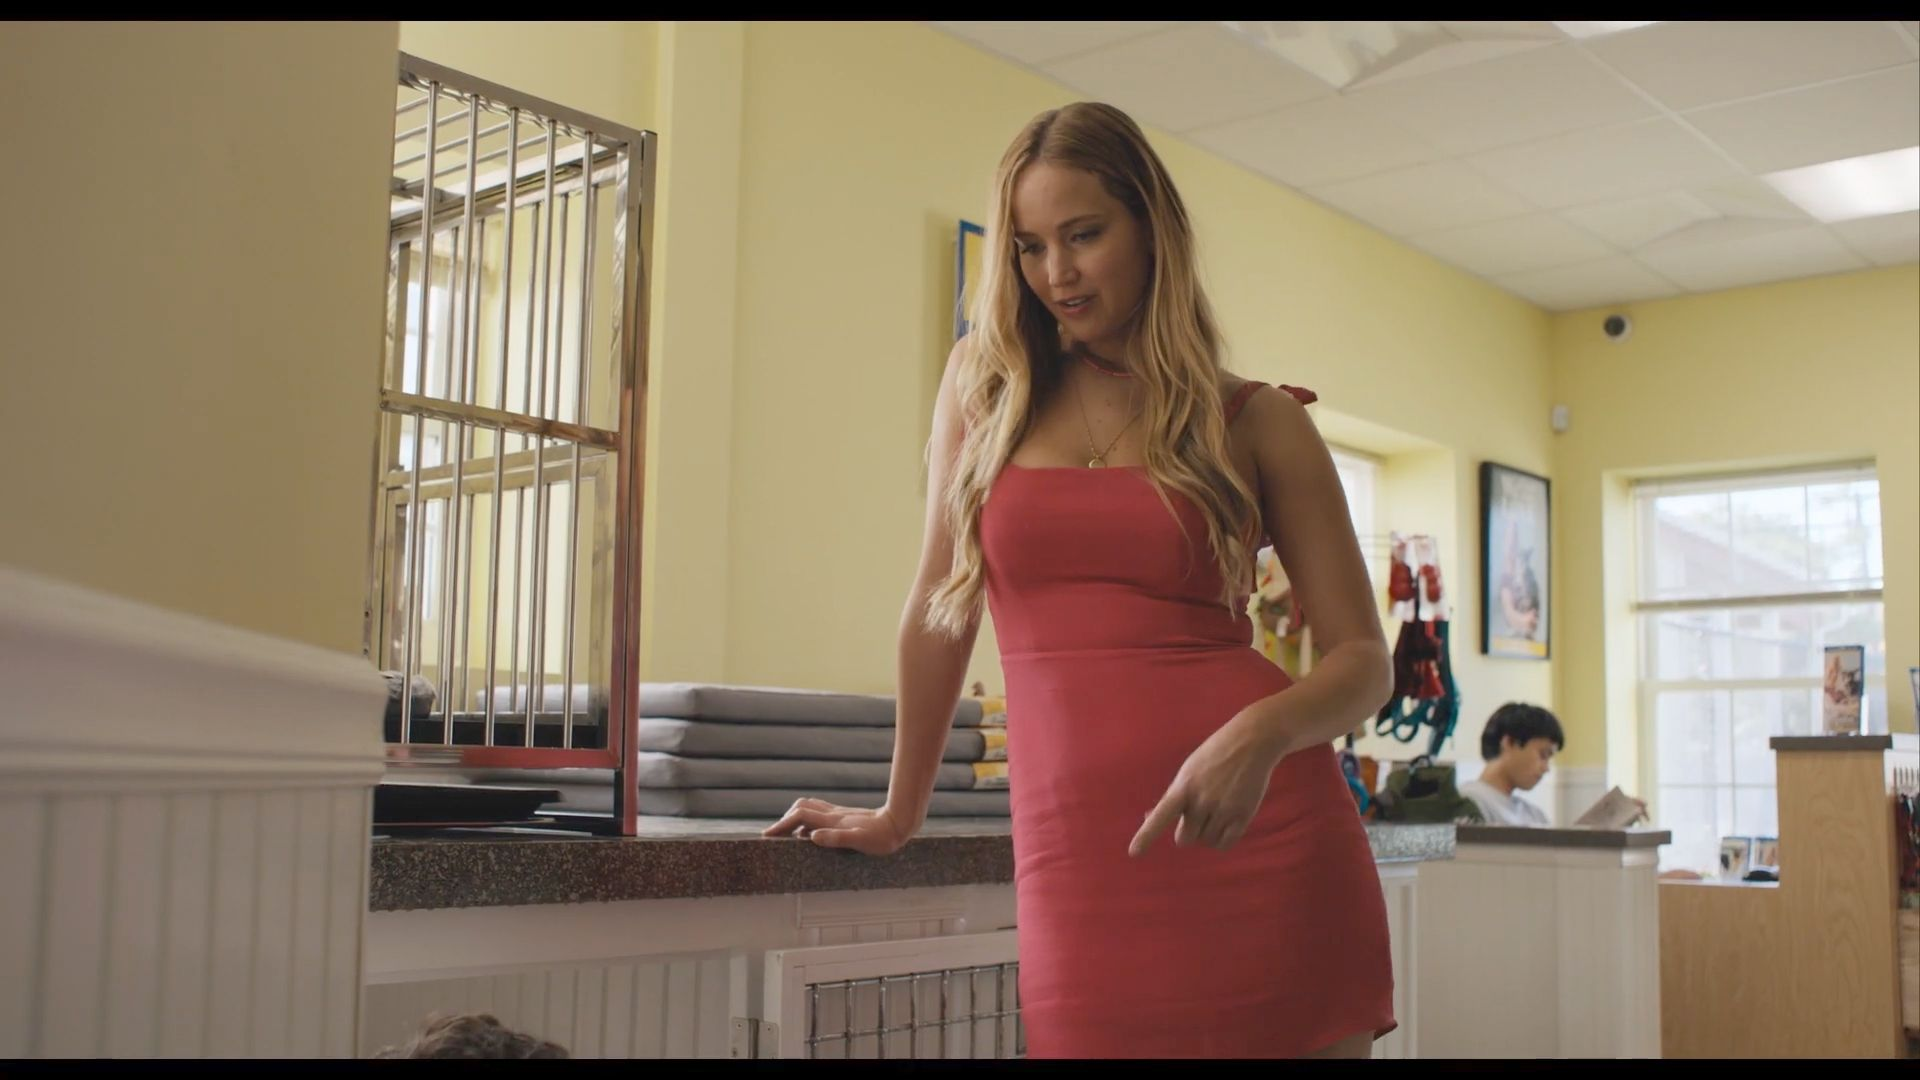Can you describe the elements shown in the background of this image? The background of the image showcases several intriguing elements that contribute to the diner's ambiance. There's a barred window that hints at an older building style or a specific security feature. Further, there are decorative items like framed pictures hanging on the yellow walls, which add a personal touch to the diner's environment. 